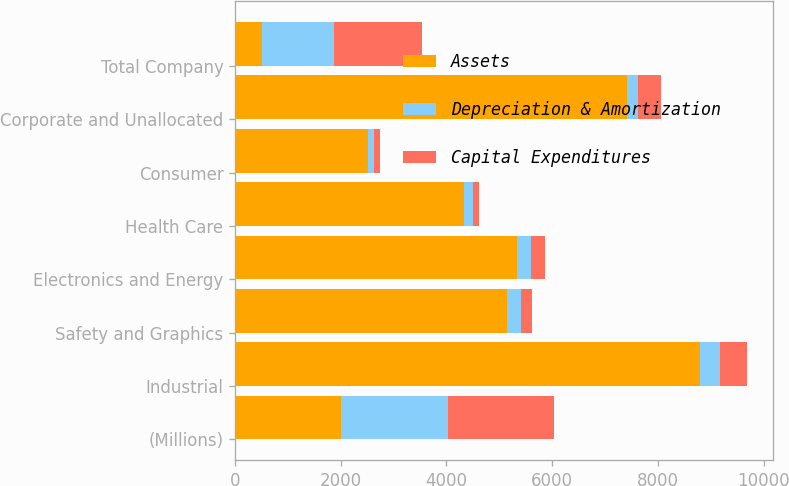Convert chart. <chart><loc_0><loc_0><loc_500><loc_500><stacked_bar_chart><ecel><fcel>(Millions)<fcel>Industrial<fcel>Safety and Graphics<fcel>Electronics and Energy<fcel>Health Care<fcel>Consumer<fcel>Corporate and Unallocated<fcel>Total Company<nl><fcel>Assets<fcel>2013<fcel>8803<fcel>5153<fcel>5336<fcel>4329<fcel>2516<fcel>7413<fcel>510<nl><fcel>Depreciation & Amortization<fcel>2013<fcel>372<fcel>256<fcel>260<fcel>171<fcel>106<fcel>206<fcel>1371<nl><fcel>Capital Expenditures<fcel>2013<fcel>510<fcel>209<fcel>261<fcel>120<fcel>128<fcel>437<fcel>1665<nl></chart> 